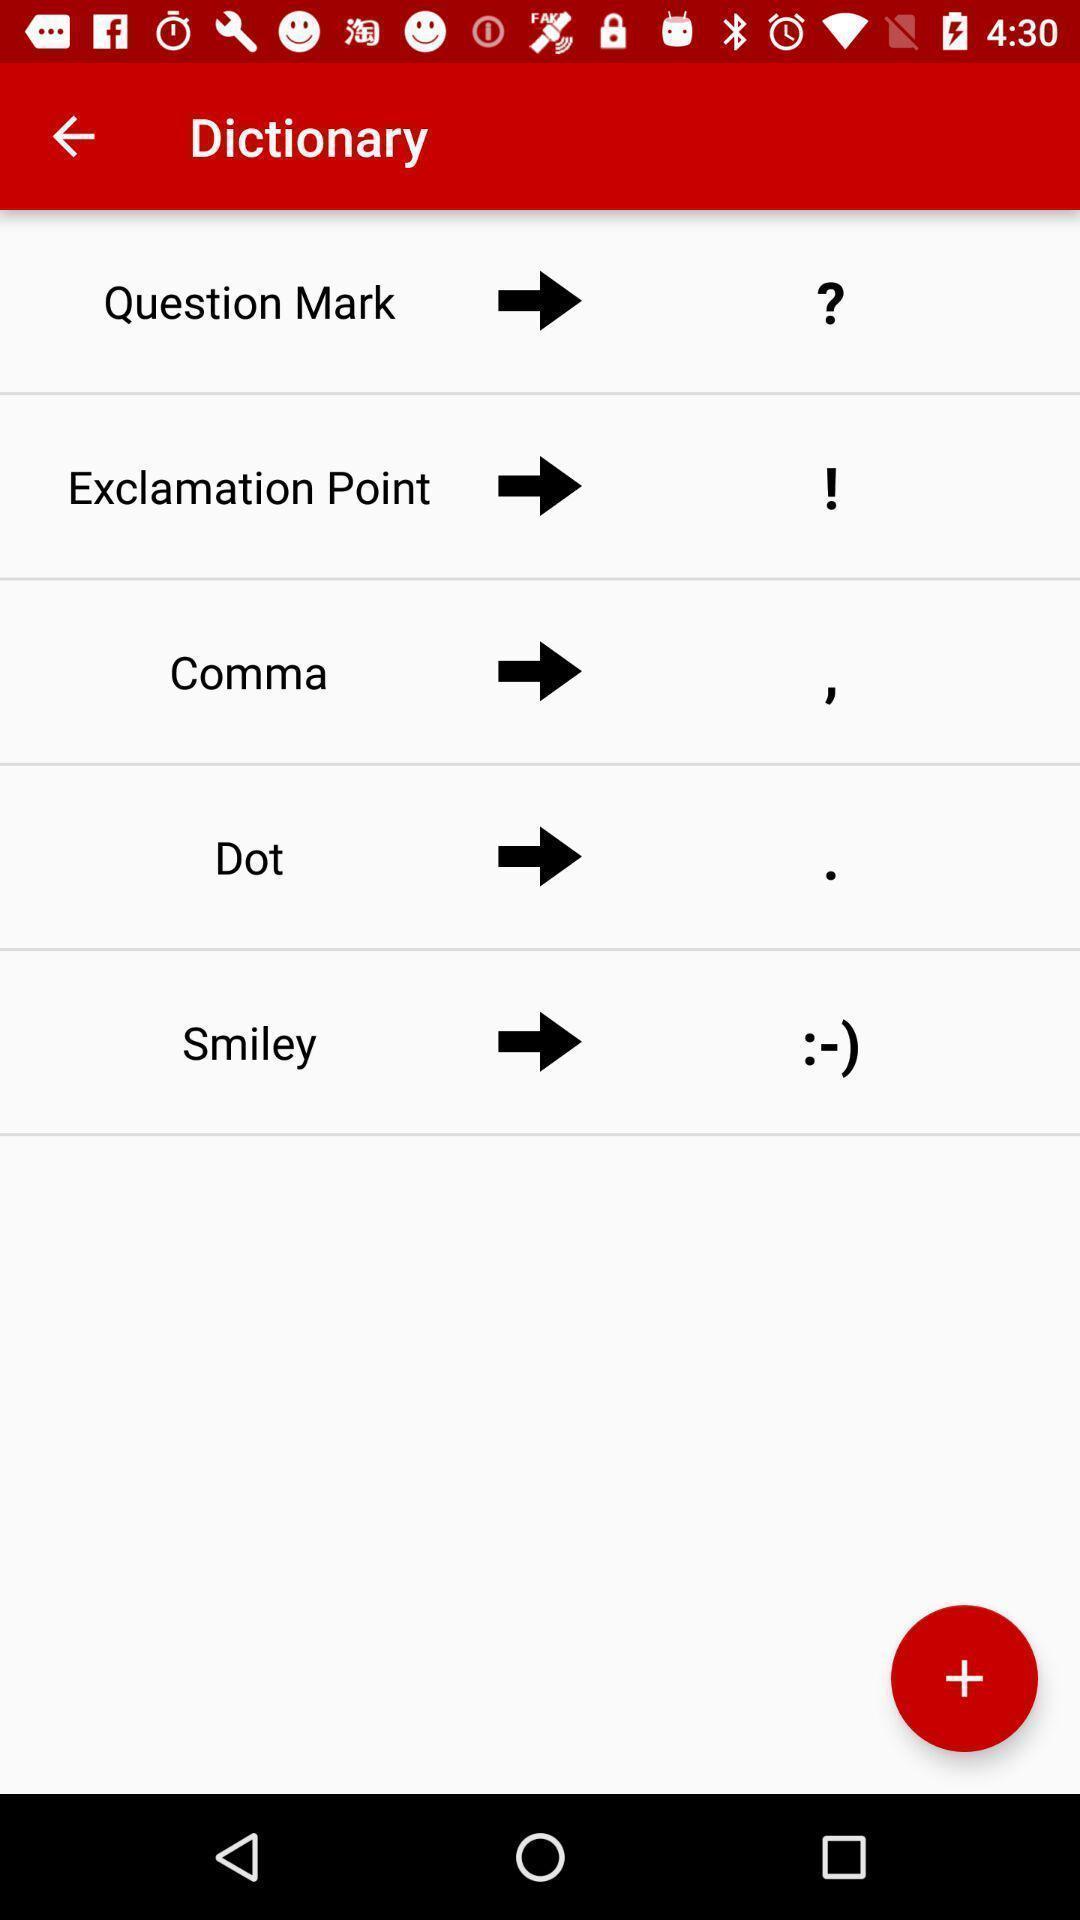Provide a textual representation of this image. Screen shows a list of dictionaries. 